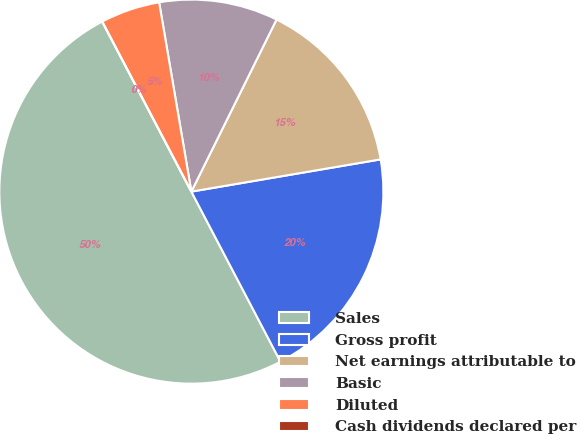Convert chart. <chart><loc_0><loc_0><loc_500><loc_500><pie_chart><fcel>Sales<fcel>Gross profit<fcel>Net earnings attributable to<fcel>Basic<fcel>Diluted<fcel>Cash dividends declared per<nl><fcel>50.0%<fcel>20.0%<fcel>15.0%<fcel>10.0%<fcel>5.0%<fcel>0.0%<nl></chart> 